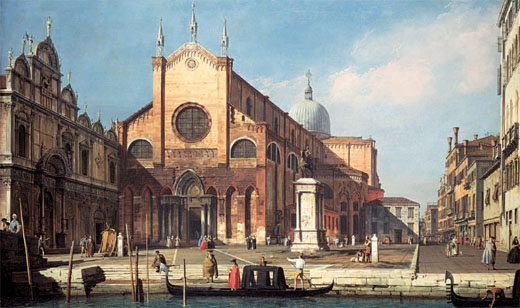What do you think is going on in this snapshot? This image transports us to a serene Venetian cityscape. The centerpiece is an imposing Gothic church, recognizable by its detailed architecture, prominent dome, and twin towers. The structure's reddish-brown hues, meticulously crafted features, and the bustling activity in front, capture the essence of Venice. The artist's use of warm colors breathes life into the stone facades and reflects the vibrant energy of the city. The mingling crowds in the foreground, coupled with distant buildings, present a vivid narrative of daily life set against a backdrop of architectural splendor. 